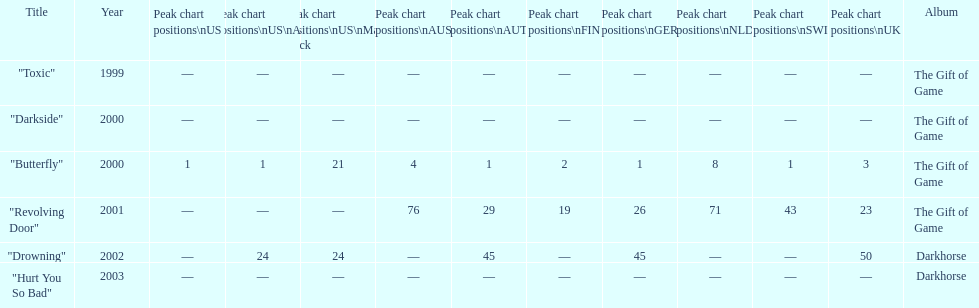How many times did the single "butterfly" rank as 1 in the chart? 5. 